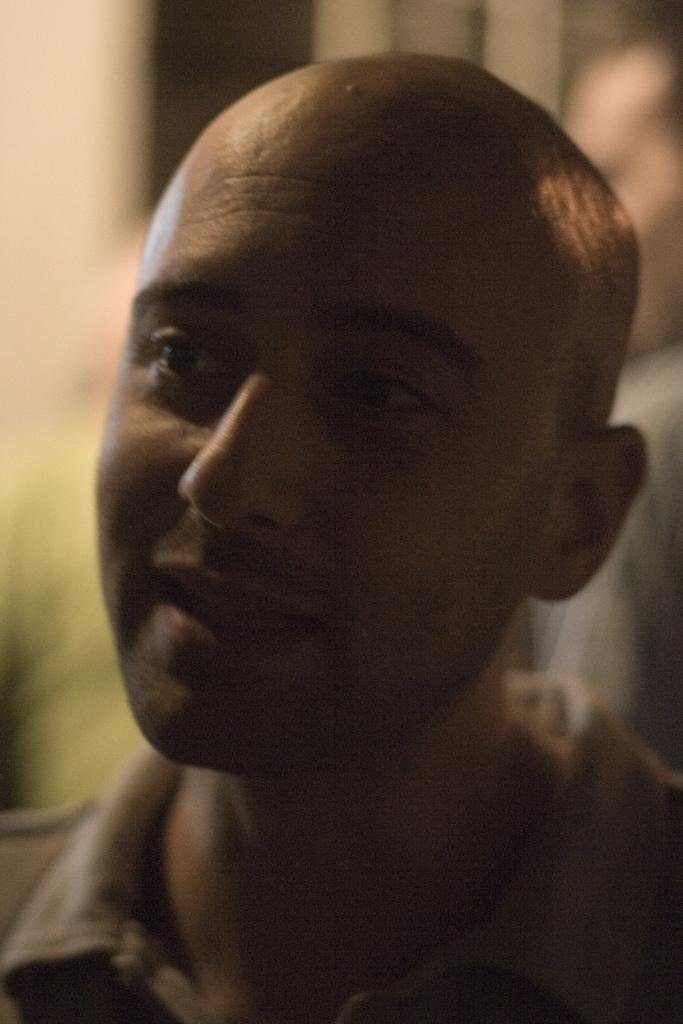What is the main subject of the image? The main subject of the image is a group of people. What are the people in the image doing? The people are standing. What type of lettuce can be seen on the sofa in the image? There is no lettuce or sofa present in the image; it only features a group of people standing. 